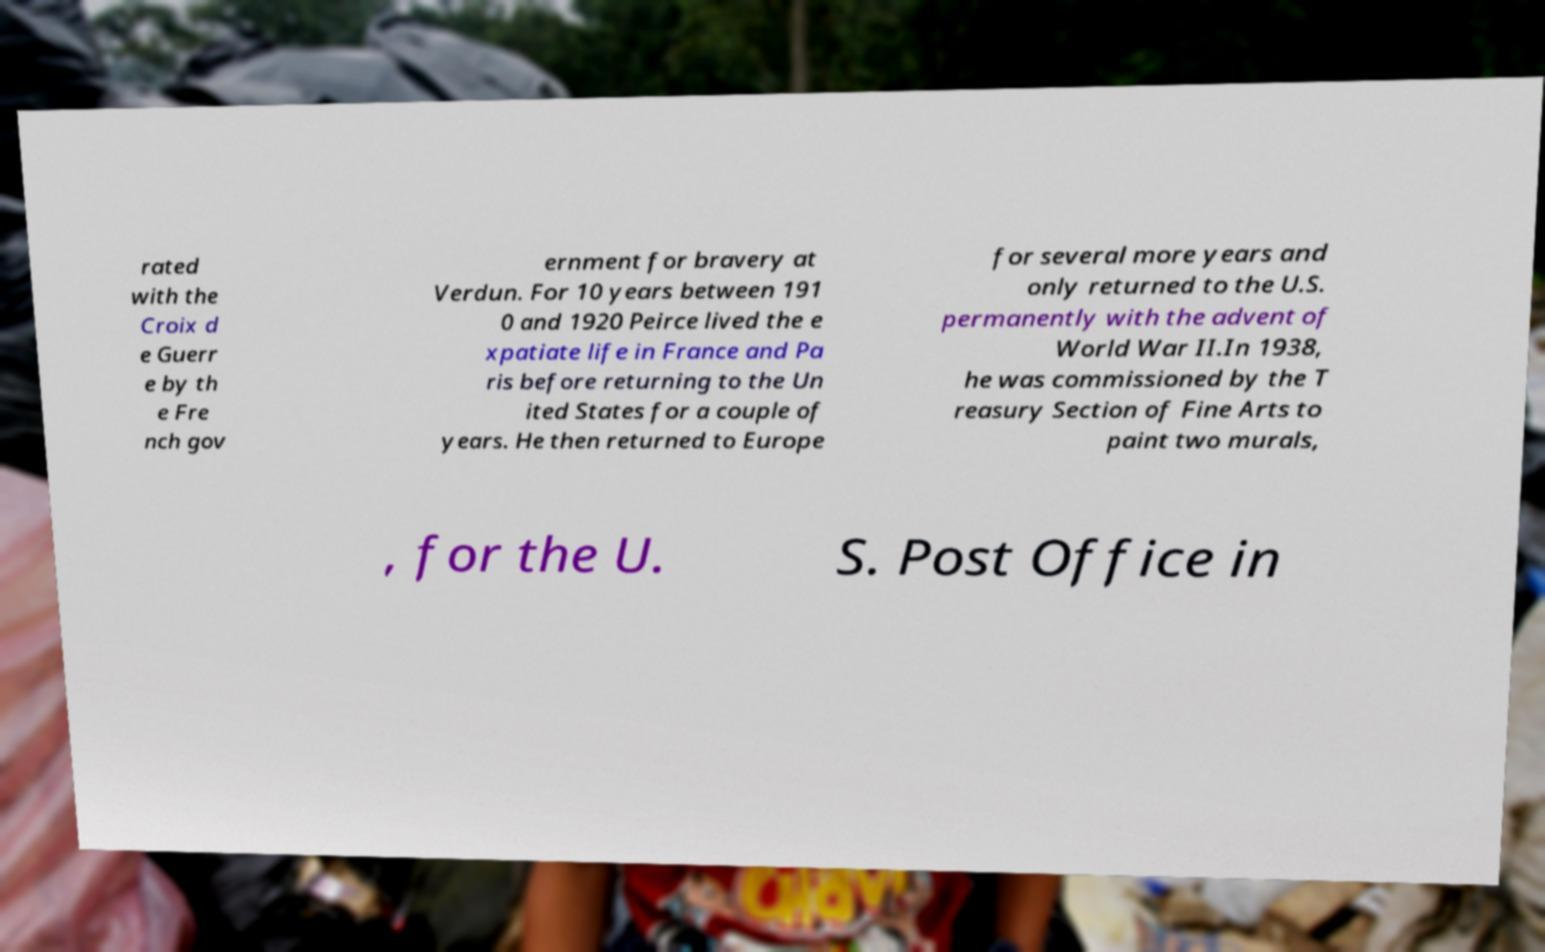For documentation purposes, I need the text within this image transcribed. Could you provide that? rated with the Croix d e Guerr e by th e Fre nch gov ernment for bravery at Verdun. For 10 years between 191 0 and 1920 Peirce lived the e xpatiate life in France and Pa ris before returning to the Un ited States for a couple of years. He then returned to Europe for several more years and only returned to the U.S. permanently with the advent of World War II.In 1938, he was commissioned by the T reasury Section of Fine Arts to paint two murals, , for the U. S. Post Office in 